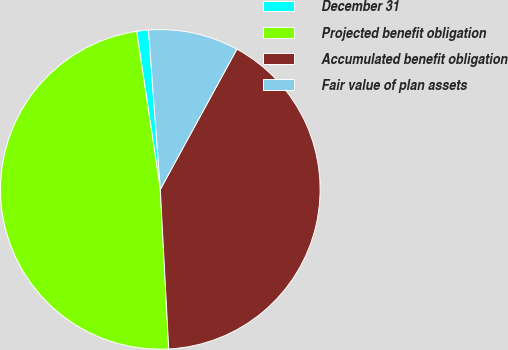Convert chart. <chart><loc_0><loc_0><loc_500><loc_500><pie_chart><fcel>December 31<fcel>Projected benefit obligation<fcel>Accumulated benefit obligation<fcel>Fair value of plan assets<nl><fcel>1.19%<fcel>48.47%<fcel>41.2%<fcel>9.13%<nl></chart> 